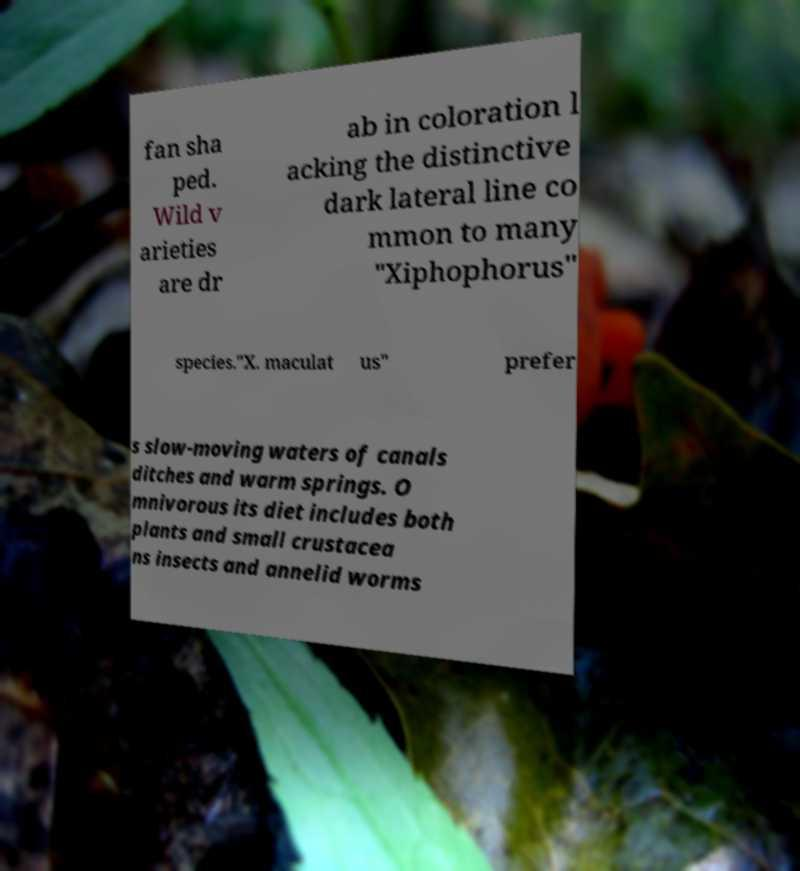Please read and relay the text visible in this image. What does it say? fan sha ped. Wild v arieties are dr ab in coloration l acking the distinctive dark lateral line co mmon to many "Xiphophorus" species."X. maculat us" prefer s slow-moving waters of canals ditches and warm springs. O mnivorous its diet includes both plants and small crustacea ns insects and annelid worms 